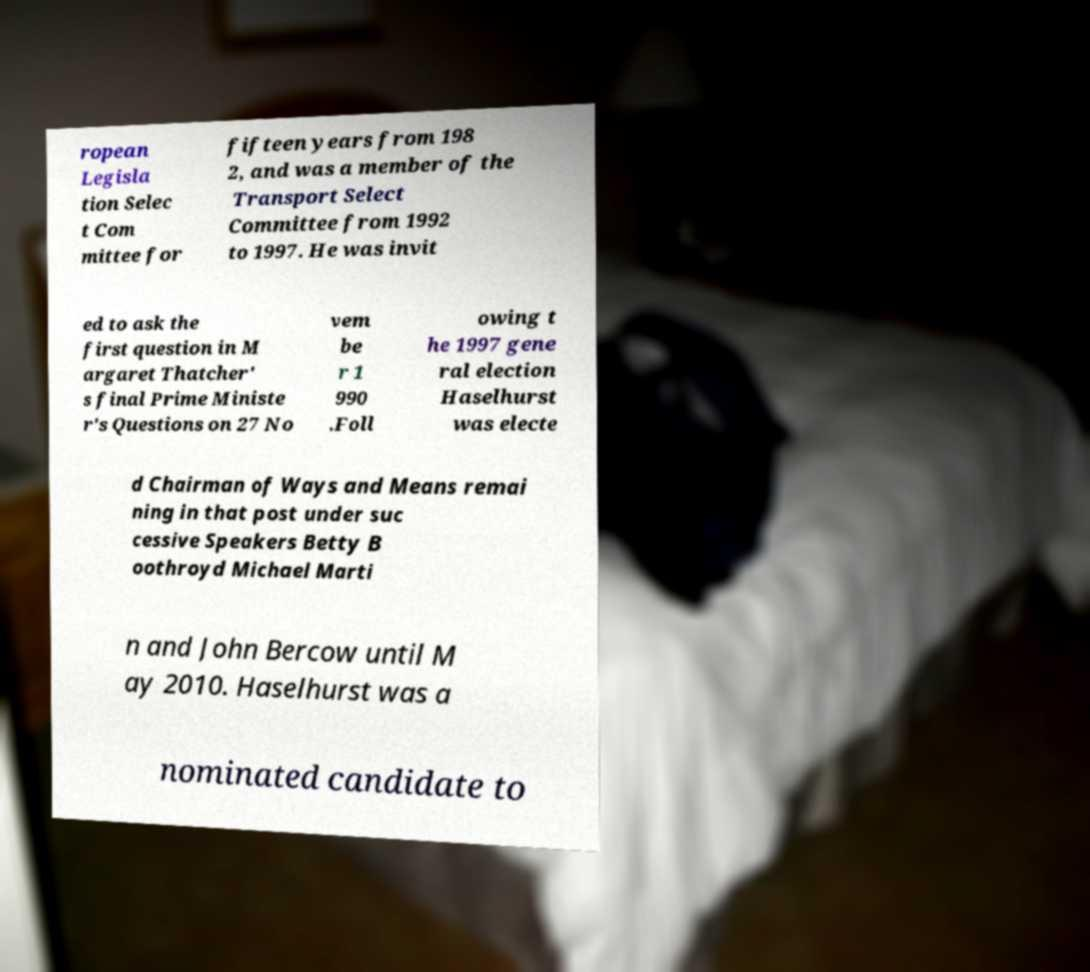Can you read and provide the text displayed in the image?This photo seems to have some interesting text. Can you extract and type it out for me? ropean Legisla tion Selec t Com mittee for fifteen years from 198 2, and was a member of the Transport Select Committee from 1992 to 1997. He was invit ed to ask the first question in M argaret Thatcher' s final Prime Ministe r's Questions on 27 No vem be r 1 990 .Foll owing t he 1997 gene ral election Haselhurst was electe d Chairman of Ways and Means remai ning in that post under suc cessive Speakers Betty B oothroyd Michael Marti n and John Bercow until M ay 2010. Haselhurst was a nominated candidate to 